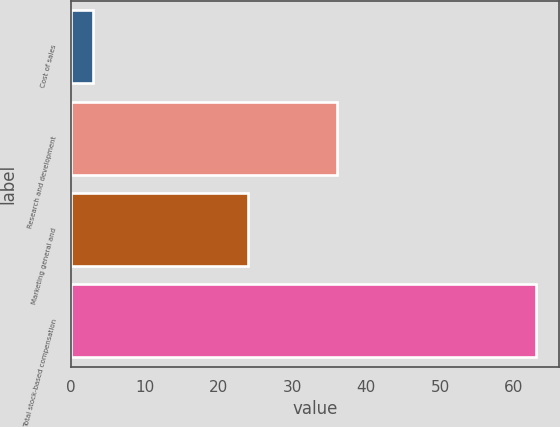Convert chart. <chart><loc_0><loc_0><loc_500><loc_500><bar_chart><fcel>Cost of sales<fcel>Research and development<fcel>Marketing general and<fcel>Total stock-based compensation<nl><fcel>3<fcel>36<fcel>24<fcel>63<nl></chart> 